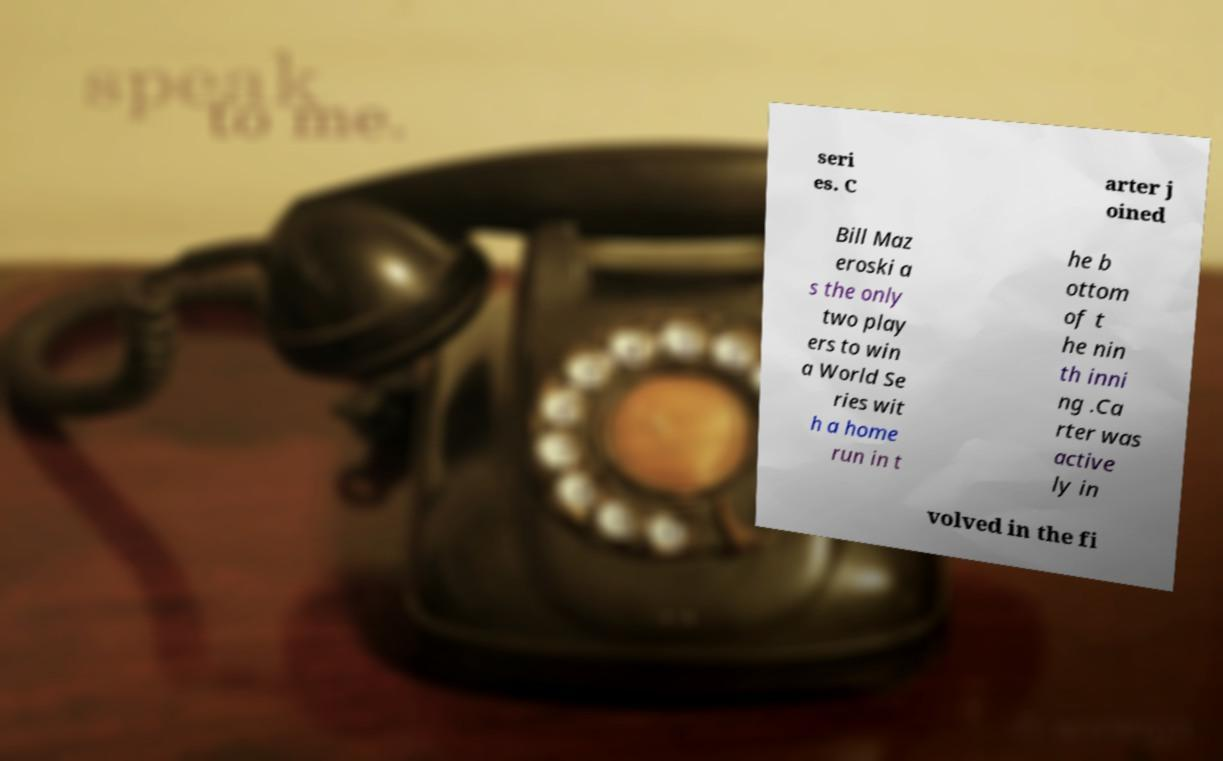Please read and relay the text visible in this image. What does it say? seri es. C arter j oined Bill Maz eroski a s the only two play ers to win a World Se ries wit h a home run in t he b ottom of t he nin th inni ng .Ca rter was active ly in volved in the fi 